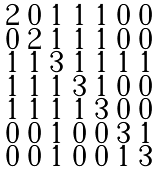<formula> <loc_0><loc_0><loc_500><loc_500>\begin{smallmatrix} 2 & 0 & 1 & 1 & 1 & 0 & 0 \\ 0 & 2 & 1 & 1 & 1 & 0 & 0 \\ 1 & 1 & 3 & 1 & 1 & 1 & 1 \\ 1 & 1 & 1 & 3 & 1 & 0 & 0 \\ 1 & 1 & 1 & 1 & 3 & 0 & 0 \\ 0 & 0 & 1 & 0 & 0 & 3 & 1 \\ 0 & 0 & 1 & 0 & 0 & 1 & 3 \end{smallmatrix}</formula> 